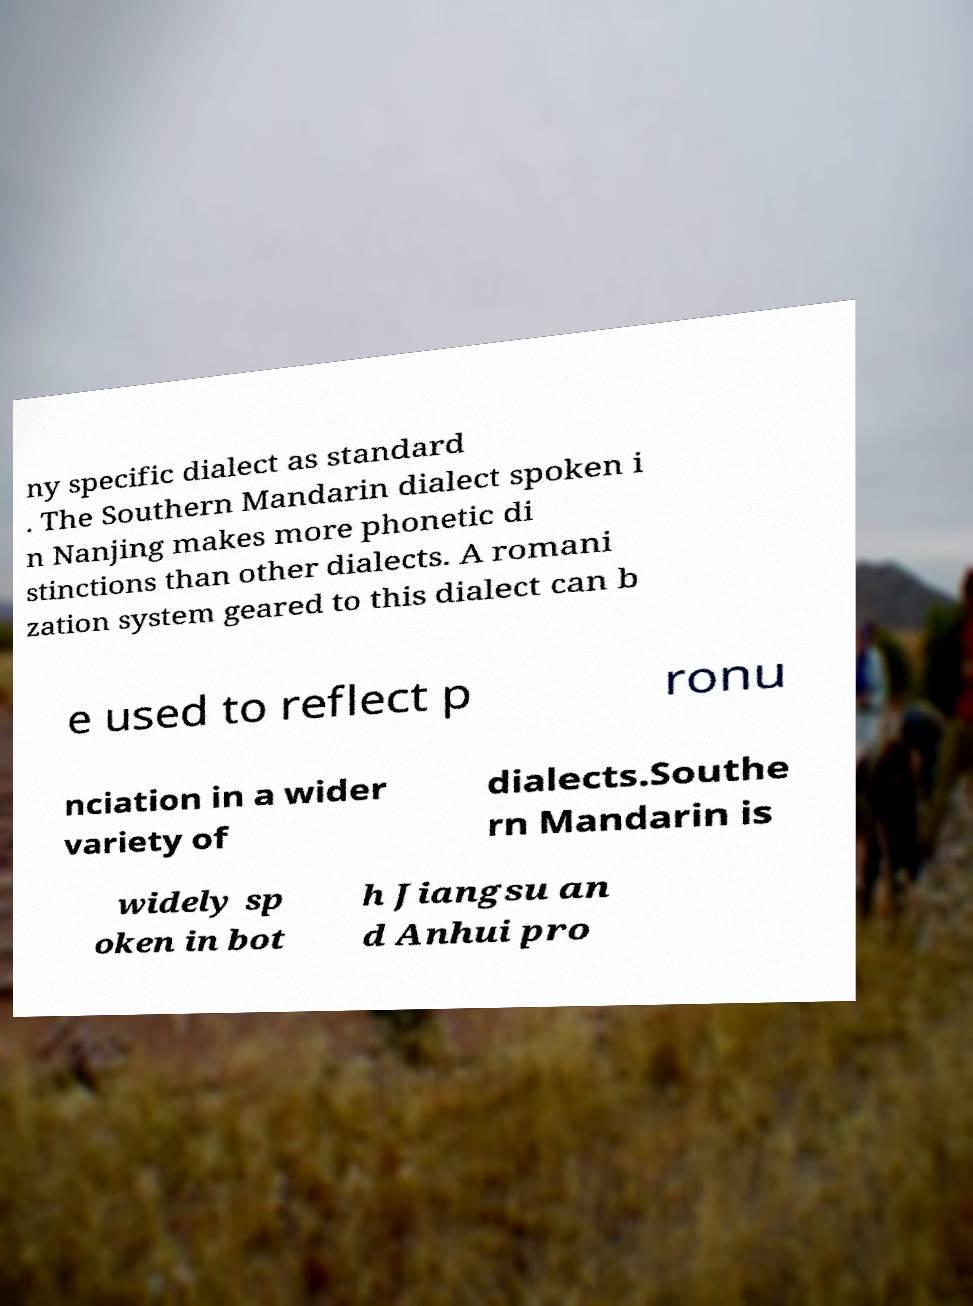I need the written content from this picture converted into text. Can you do that? ny specific dialect as standard . The Southern Mandarin dialect spoken i n Nanjing makes more phonetic di stinctions than other dialects. A romani zation system geared to this dialect can b e used to reflect p ronu nciation in a wider variety of dialects.Southe rn Mandarin is widely sp oken in bot h Jiangsu an d Anhui pro 